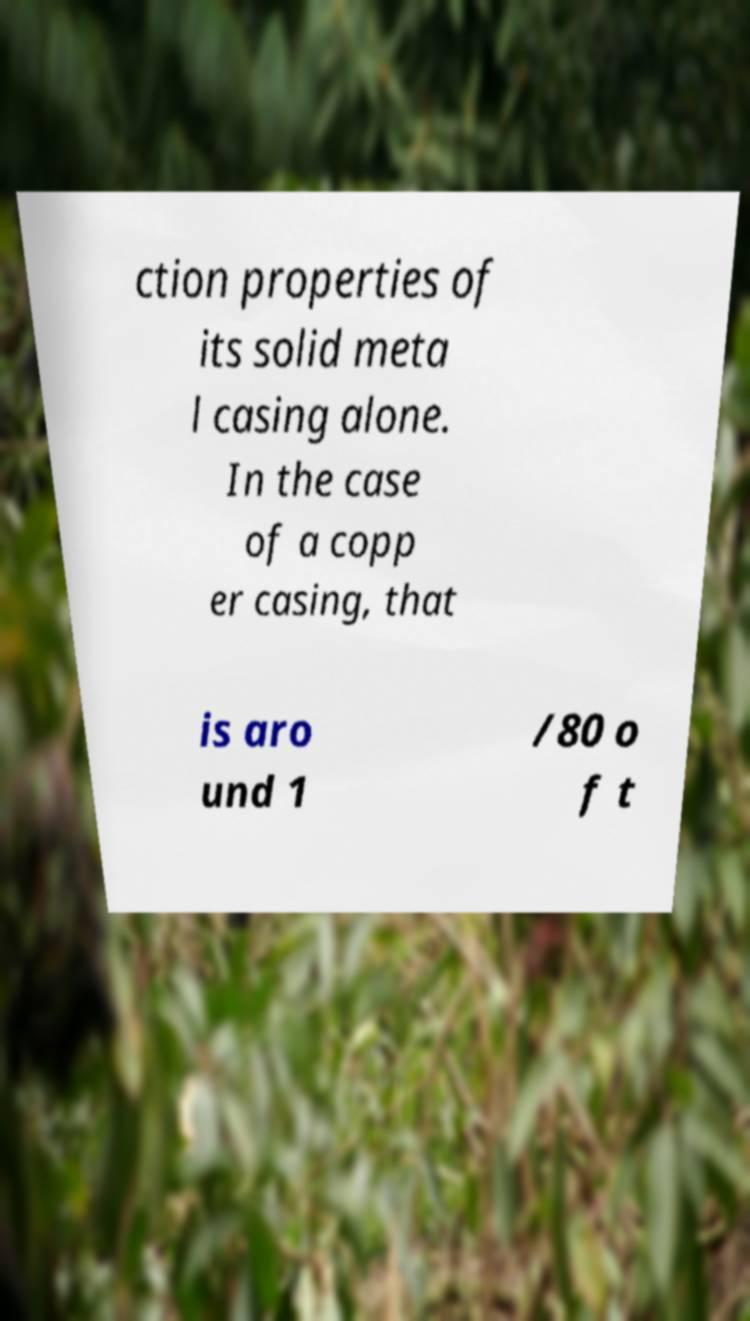There's text embedded in this image that I need extracted. Can you transcribe it verbatim? ction properties of its solid meta l casing alone. In the case of a copp er casing, that is aro und 1 /80 o f t 